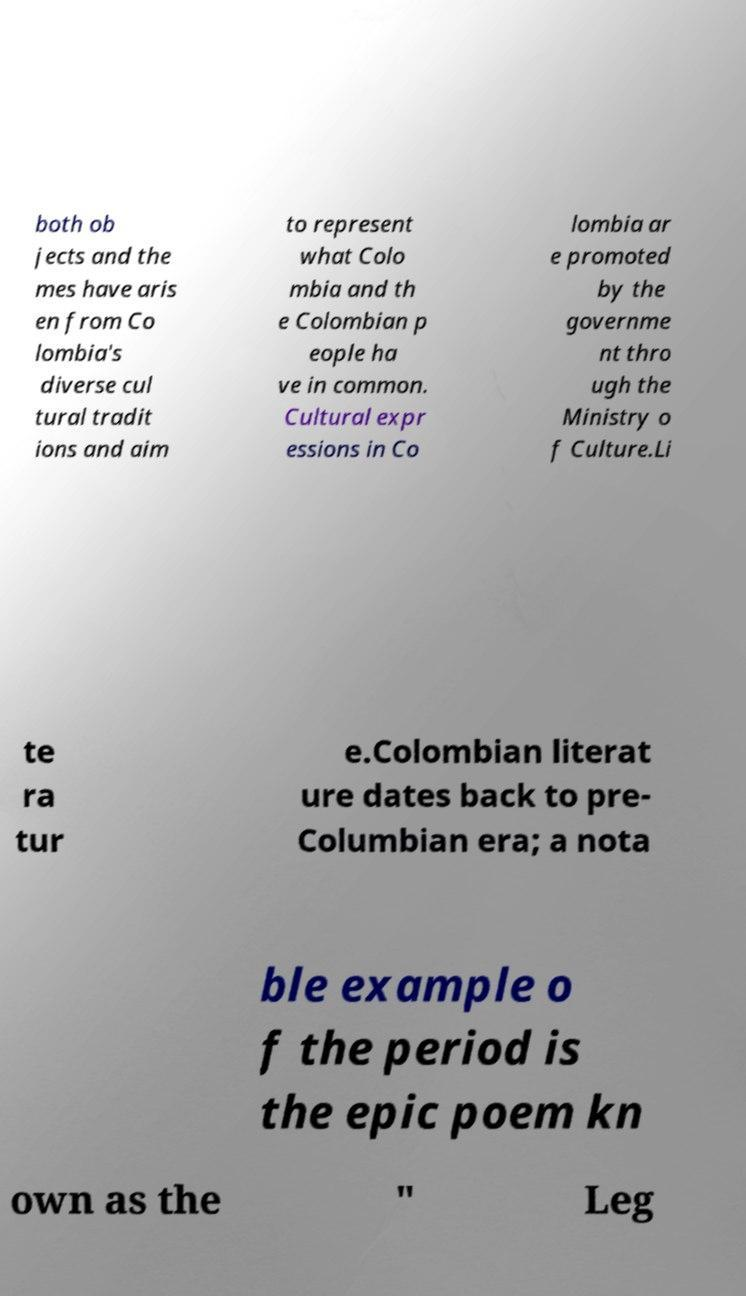Could you assist in decoding the text presented in this image and type it out clearly? both ob jects and the mes have aris en from Co lombia's diverse cul tural tradit ions and aim to represent what Colo mbia and th e Colombian p eople ha ve in common. Cultural expr essions in Co lombia ar e promoted by the governme nt thro ugh the Ministry o f Culture.Li te ra tur e.Colombian literat ure dates back to pre- Columbian era; a nota ble example o f the period is the epic poem kn own as the " Leg 